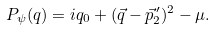<formula> <loc_0><loc_0><loc_500><loc_500>P _ { \psi } ( q ) = i q _ { 0 } + ( \vec { q } - \vec { p } _ { 2 } ^ { \, \prime } ) ^ { 2 } - \mu .</formula> 